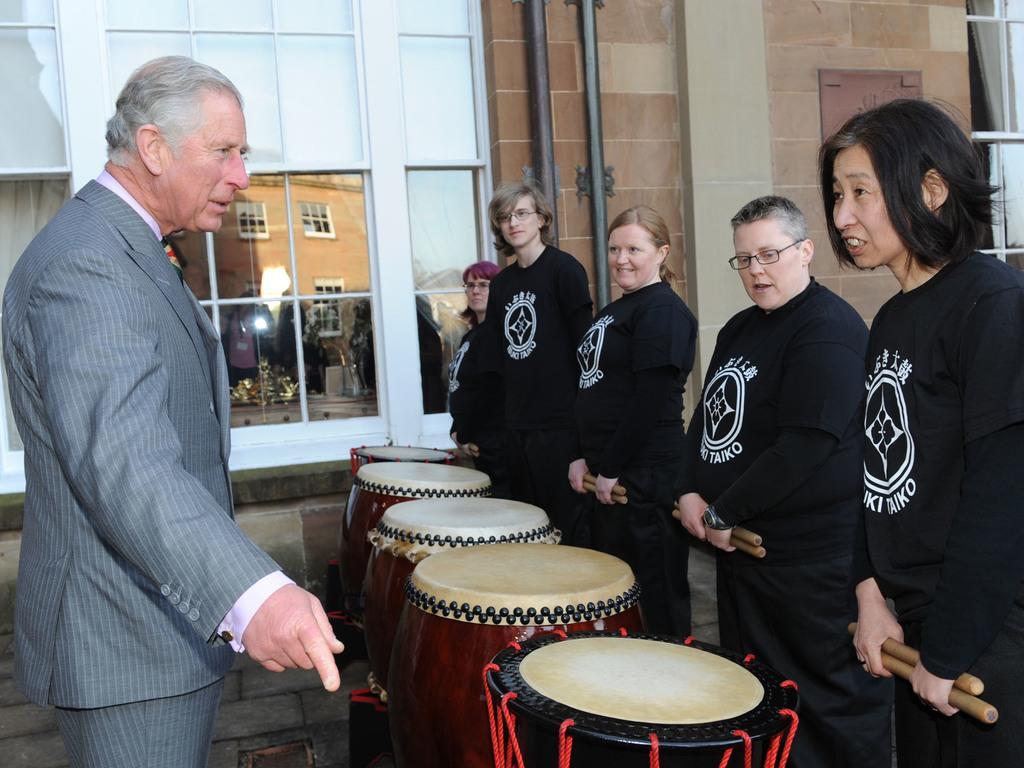How would you summarize this image in a sentence or two? In this image consist of a five person standing and wearing a black color jackets on the right side corners in front of them there are the drugs kept on the floor with red color and left side a men wearing a jacket with gray color. Back side of him there is a window through the window i can a see a building 